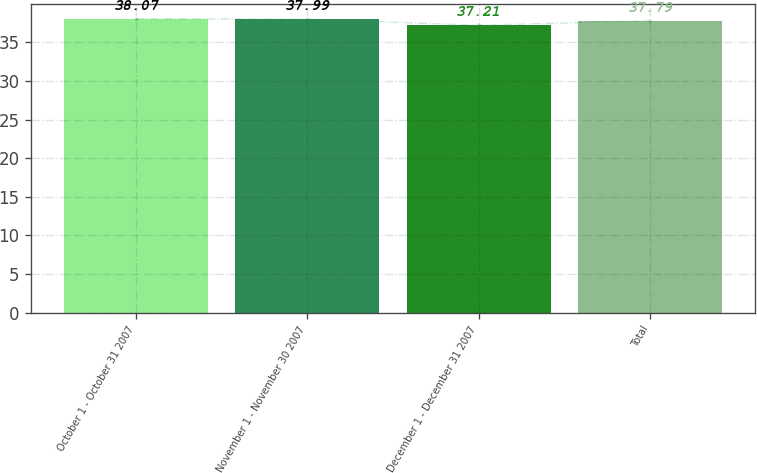<chart> <loc_0><loc_0><loc_500><loc_500><bar_chart><fcel>October 1 - October 31 2007<fcel>November 1 - November 30 2007<fcel>December 1 - December 31 2007<fcel>Total<nl><fcel>38.07<fcel>37.99<fcel>37.21<fcel>37.79<nl></chart> 